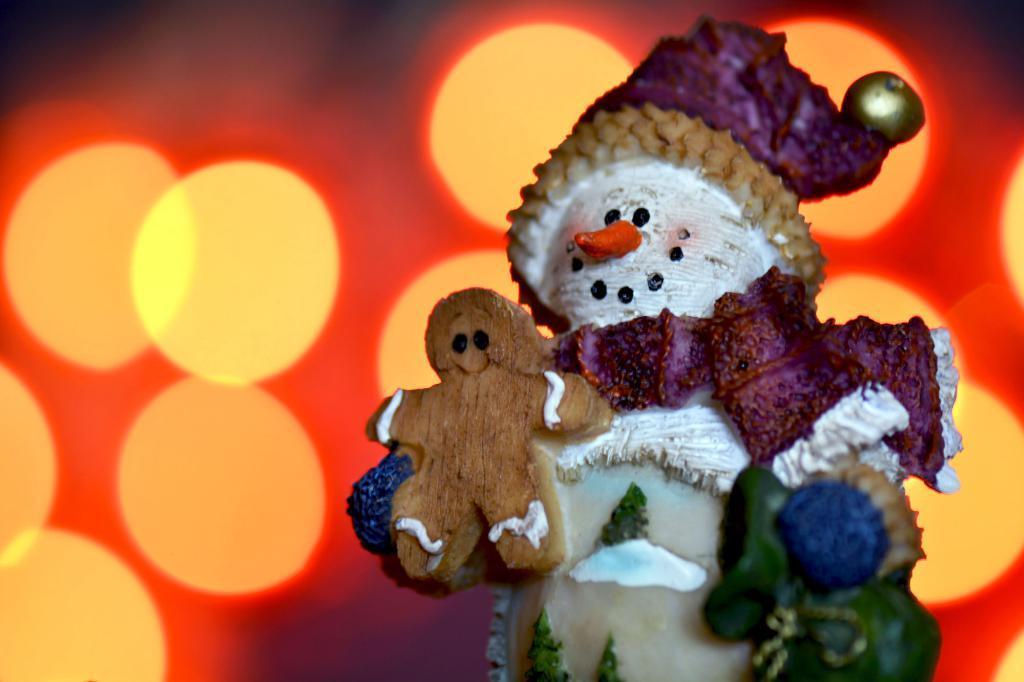Please provide a concise description of this image. This is a zoomed in picture. On the right there is a sculpture of a joker holding a teddy bear. In the background we can see the lights. 